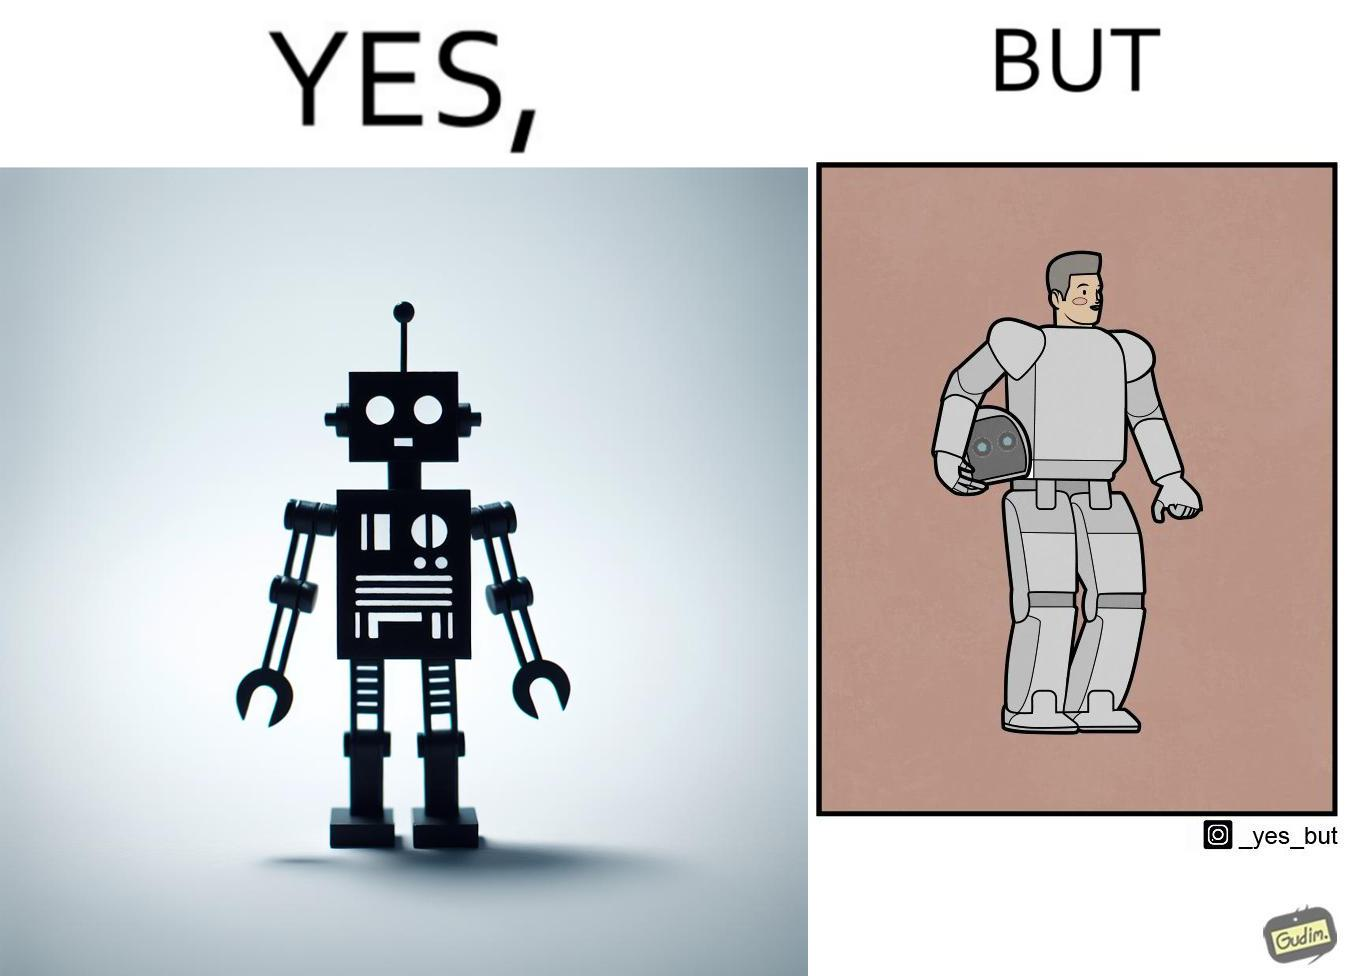What do you see in each half of this image? In the left part of the image: It is a robot In the right part of the image: It is a human in a robot suit 